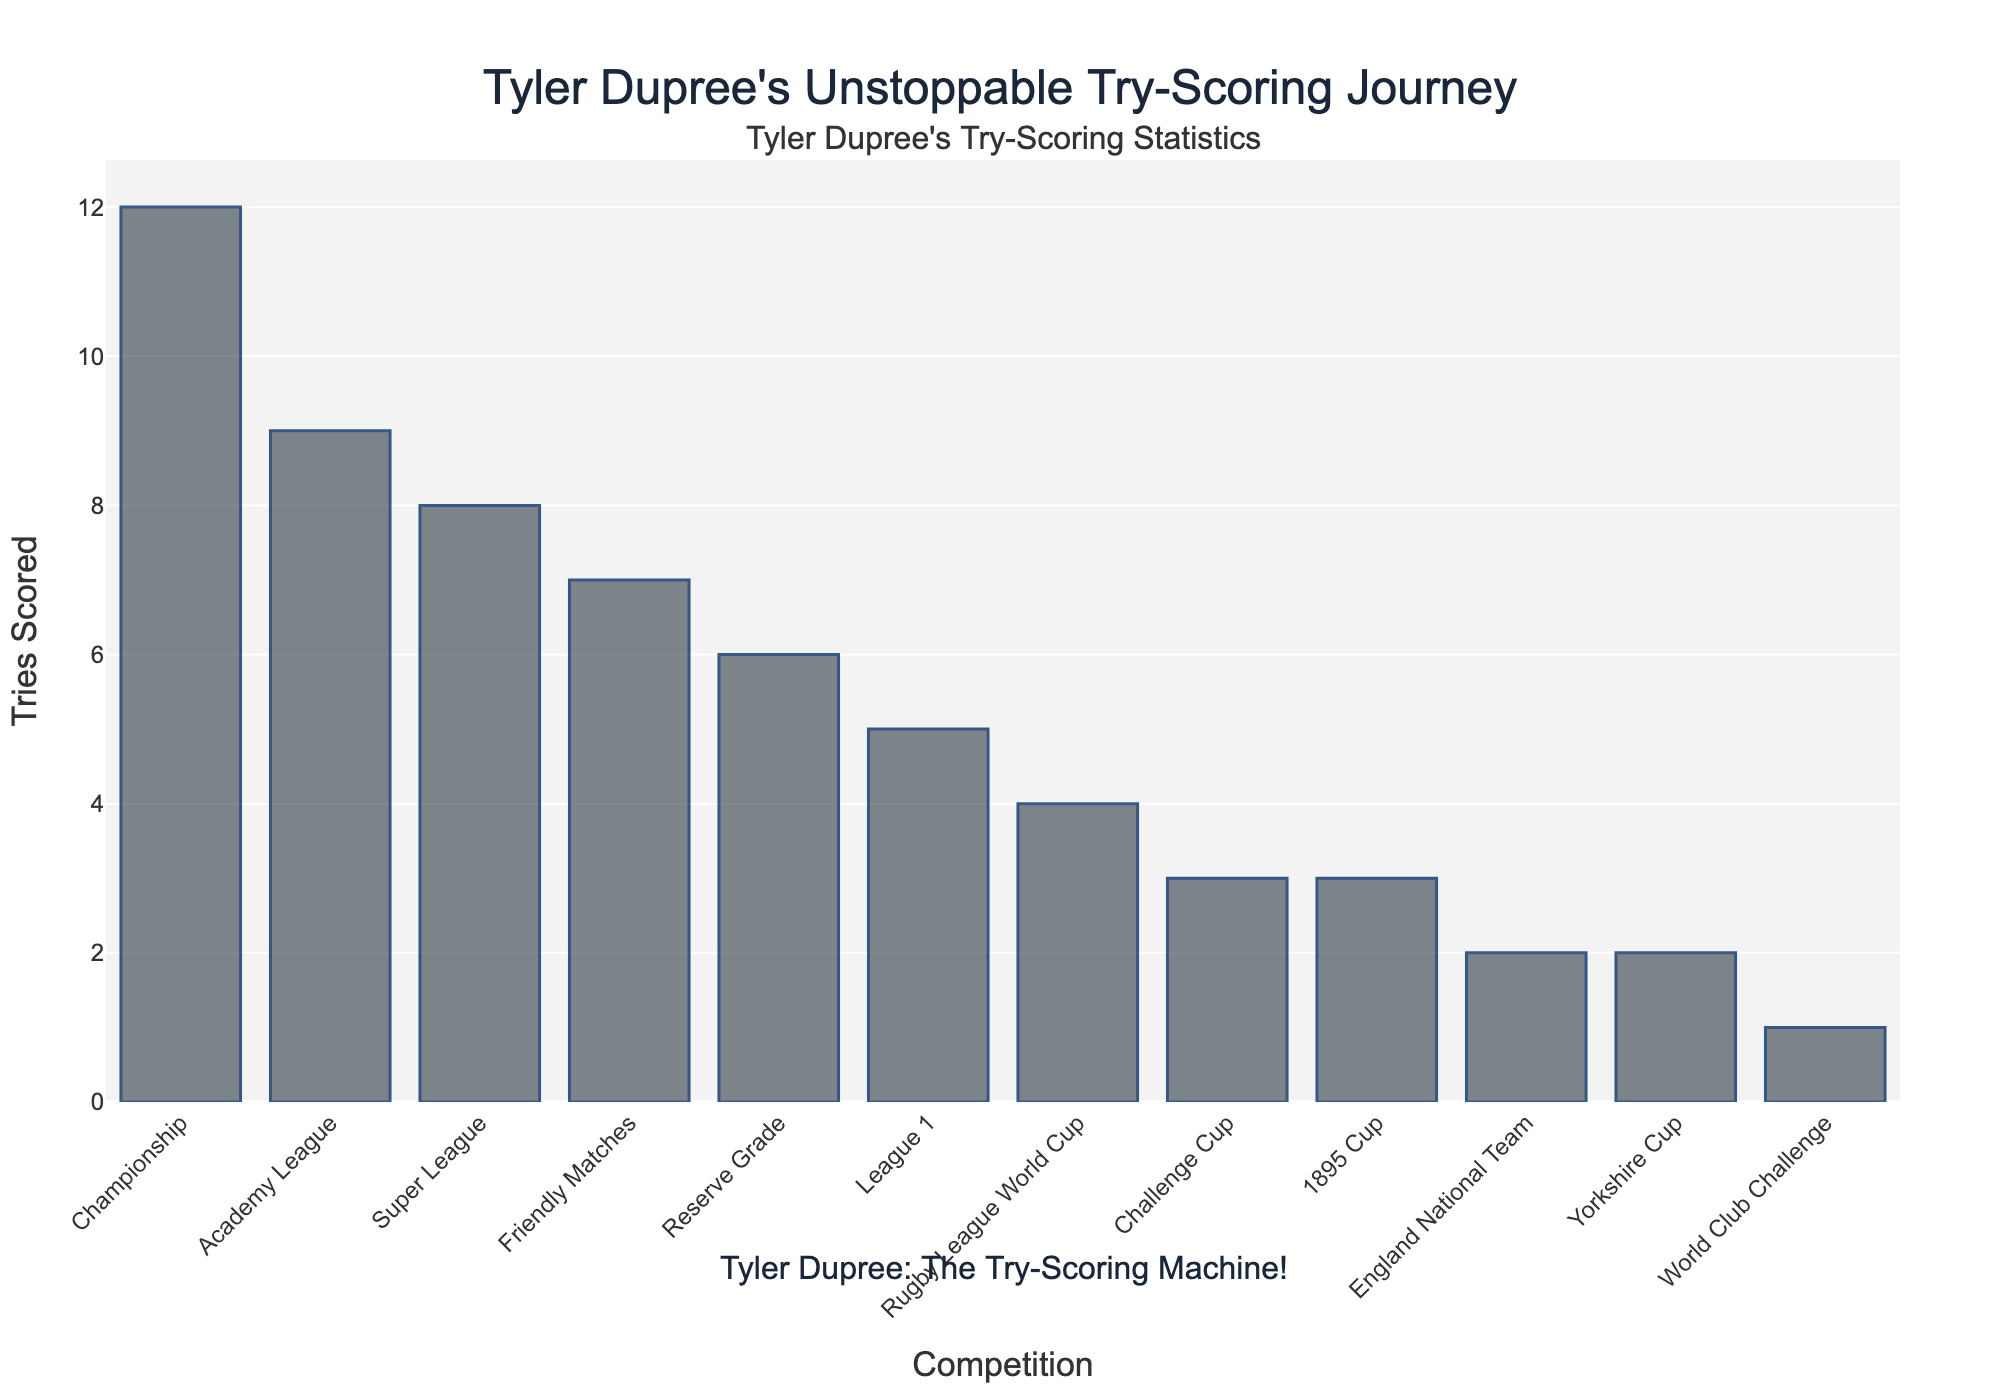Which competition did Tyler Dupree score the most tries in? The bar representing the Championship is the tallest, indicating the highest number of tries scored.
Answer: Championship How many more tries did Tyler Dupree score in the Super League compared to the Challenge Cup? Tyler scored 8 tries in the Super League and 3 in the Challenge Cup. The difference is 8 - 3 = 5.
Answer: 5 What is the total number of tries Tyler Dupree scored in the Reserve Grade and the Academy League combined? He scored 6 tries in the Reserve Grade and 9 in the Academy League. The total is 6 + 9 = 15.
Answer: 15 Which competition had fewer tries scored by Tyler Dupree: Yorkshire Cup or 1895 Cup? Yorkshire Cup had 2 tries and 1895 Cup had 3 tries. Yorkshire Cup had fewer tries.
Answer: Yorkshire Cup What is the average number of tries Tyler Dupree scored across all competitions? Sum the total tries across all competitions: 8 + 3 + 12 + 5 + 1 + 2 + 4 + 2 + 3 + 6 + 9 + 7 = 62. There are 12 competitions, so the average is 62 / 12 ≈ 5.17.
Answer: 5.17 Which competition had exactly the same number of tries as the England National Team? Both the England National Team and the Yorkshire Cup had 2 tries each.
Answer: Yorkshire Cup Did Tyler Dupree score more tries in Friendly Matches or in League 1? He scored 7 tries in Friendly Matches and 5 in League 1. Friendly Matches had more tries.
Answer: Friendly Matches How many competitions did Tyler Dupree score at least 5 tries in? The competitions with at least 5 tries are Super League (8), Championship (12), League 1 (5), Reserve Grade (6), Academy League (9), and Friendly Matches (7). There are 6 such competitions.
Answer: 6 What is the difference in the number of tries between the World Club Challenge and Rugby League World Cup? World Club Challenge had 1 try and Rugby League World Cup had 4 tries. The difference is 4 - 1 = 3.
Answer: 3 Which competition had the second highest number of tries scored by Tyler Dupree? The Championship had the most tries (12), and the Academy League had the second highest with 9 tries.
Answer: Academy League 